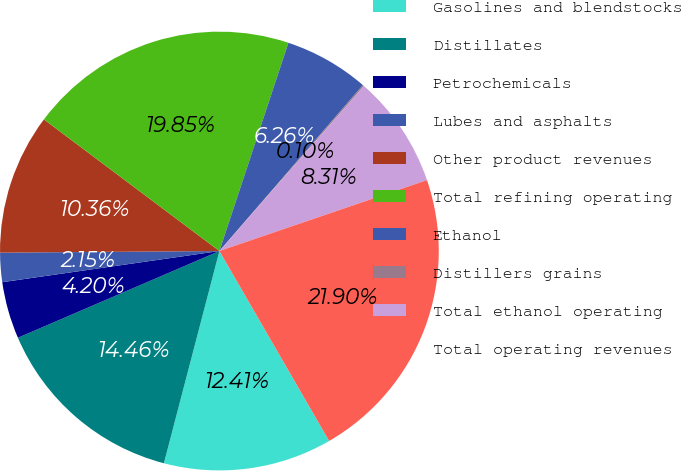Convert chart to OTSL. <chart><loc_0><loc_0><loc_500><loc_500><pie_chart><fcel>Gasolines and blendstocks<fcel>Distillates<fcel>Petrochemicals<fcel>Lubes and asphalts<fcel>Other product revenues<fcel>Total refining operating<fcel>Ethanol<fcel>Distillers grains<fcel>Total ethanol operating<fcel>Total operating revenues<nl><fcel>12.41%<fcel>14.46%<fcel>4.2%<fcel>2.15%<fcel>10.36%<fcel>19.85%<fcel>6.26%<fcel>0.1%<fcel>8.31%<fcel>21.9%<nl></chart> 